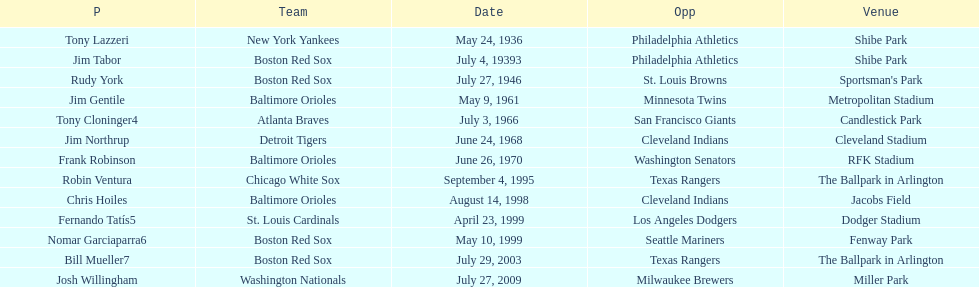What is the number of times a boston red sox player has had two grand slams in one game? 4. 